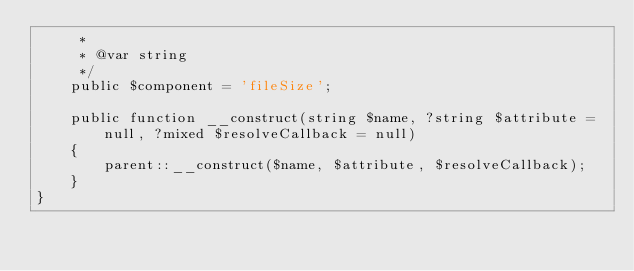Convert code to text. <code><loc_0><loc_0><loc_500><loc_500><_PHP_>     *
     * @var string
     */
    public $component = 'fileSize';

    public function __construct(string $name, ?string $attribute = null, ?mixed $resolveCallback = null)
    {
        parent::__construct($name, $attribute, $resolveCallback);
    }
}
</code> 